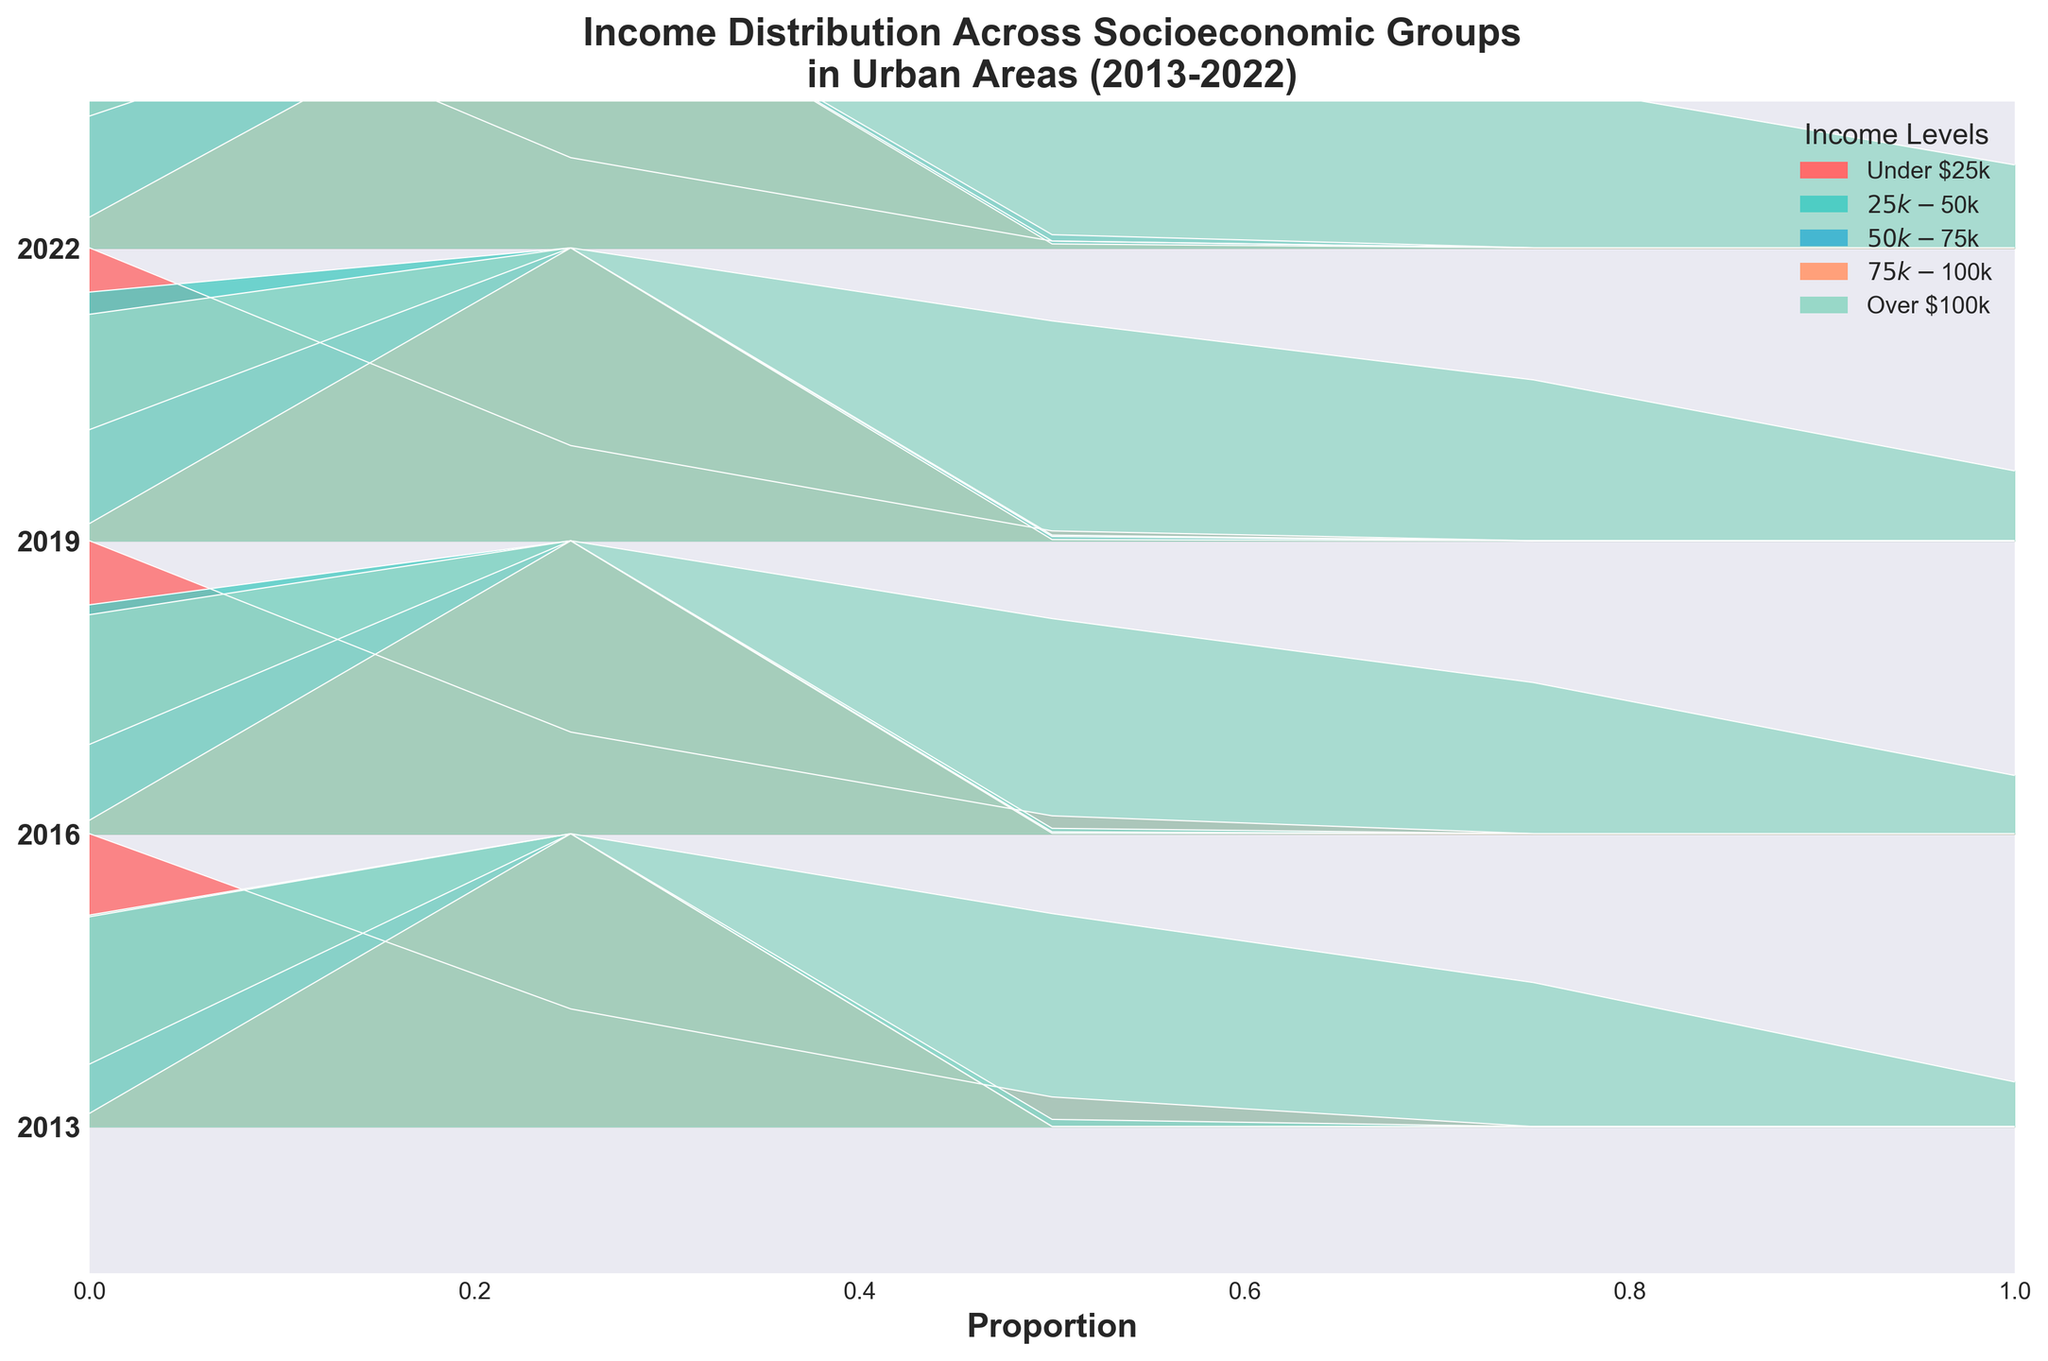What is the title of the figure? The title of the figure is written at the top and provides a brief description of the chart's contents. The title reads 'Income Distribution Across Socioeconomic Groups in Urban Areas (2013-2022)'.
Answer: Income Distribution Across Socioeconomic Groups in Urban Areas (2013-2022) How many income levels are represented in the plot? We can count the number of different colors in the legend which correspond to unique income levels. There are five colors in the legend.
Answer: 5 Which income level shows the highest proportion for the year 2022? Look for the income level with the peak of the filled curve that is highest above the baseline for 2022. 'Over $100k' shows the highest proportion in 2022.
Answer: Over $100k How has the proportion of 'Under $25k' income level changed from 2013 to 2022? Compare the heights of the filled curves for the 'Under $25k' income level in 2013 and 2022. The filled curve appears slightly lower in 2022.
Answer: Decreased What is one observable trend for middle-income levels ($50k-$75k) over the years shown? Observe the height of the filled curves for 'Middle' ($50k-$75k) level for each year. The height of this curve has generally increased slightly over time.
Answer: Slight increase Which year shows the highest proportion for 'Upper Middle' income level? Look for the year where the curve for 'Upper Middle' income level (closest to the top) has its highest peak. The year with the highest proportion is 2022.
Answer: 2022 Which income level has the smallest proportion consistently across all years? Identify the income level by observing the heights of their respective curves over multiple years. 'Under $25k' income level consistently has one of the smallest peaks.
Answer: Under $25k Compare the proportion of 'High Income' in 2013 with 2022. Has it increased or decreased? Compare the heights of the filled curves for 'High Income' in 2013 and 2022, which appear taller in 2022. The proportion has increased.
Answer: Increased Does the 'Lower Middle' income level show a steady increase or decrease over the years? Examine the curves for the 'Lower Middle' income level; the height of these curves generally shows a steady decrease over the years.
Answer: Decrease 